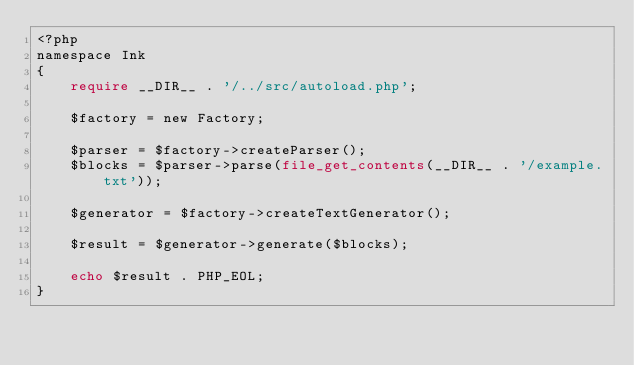Convert code to text. <code><loc_0><loc_0><loc_500><loc_500><_PHP_><?php
namespace Ink
{
    require __DIR__ . '/../src/autoload.php';

    $factory = new Factory;

    $parser = $factory->createParser();
    $blocks = $parser->parse(file_get_contents(__DIR__ . '/example.txt'));

    $generator = $factory->createTextGenerator();

    $result = $generator->generate($blocks);

    echo $result . PHP_EOL;
}
</code> 